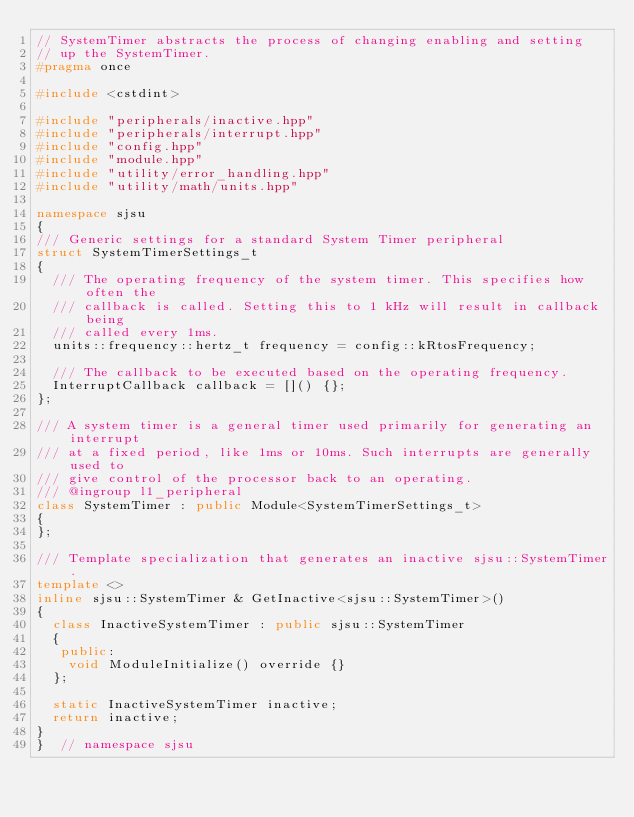<code> <loc_0><loc_0><loc_500><loc_500><_C++_>// SystemTimer abstracts the process of changing enabling and setting
// up the SystemTimer.
#pragma once

#include <cstdint>

#include "peripherals/inactive.hpp"
#include "peripherals/interrupt.hpp"
#include "config.hpp"
#include "module.hpp"
#include "utility/error_handling.hpp"
#include "utility/math/units.hpp"

namespace sjsu
{
/// Generic settings for a standard System Timer peripheral
struct SystemTimerSettings_t
{
  /// The operating frequency of the system timer. This specifies how often the
  /// callback is called. Setting this to 1 kHz will result in callback being
  /// called every 1ms.
  units::frequency::hertz_t frequency = config::kRtosFrequency;

  /// The callback to be executed based on the operating frequency.
  InterruptCallback callback = []() {};
};

/// A system timer is a general timer used primarily for generating an interrupt
/// at a fixed period, like 1ms or 10ms. Such interrupts are generally used to
/// give control of the processor back to an operating.
/// @ingroup l1_peripheral
class SystemTimer : public Module<SystemTimerSettings_t>
{
};

/// Template specialization that generates an inactive sjsu::SystemTimer.
template <>
inline sjsu::SystemTimer & GetInactive<sjsu::SystemTimer>()
{
  class InactiveSystemTimer : public sjsu::SystemTimer
  {
   public:
    void ModuleInitialize() override {}
  };

  static InactiveSystemTimer inactive;
  return inactive;
}
}  // namespace sjsu
</code> 